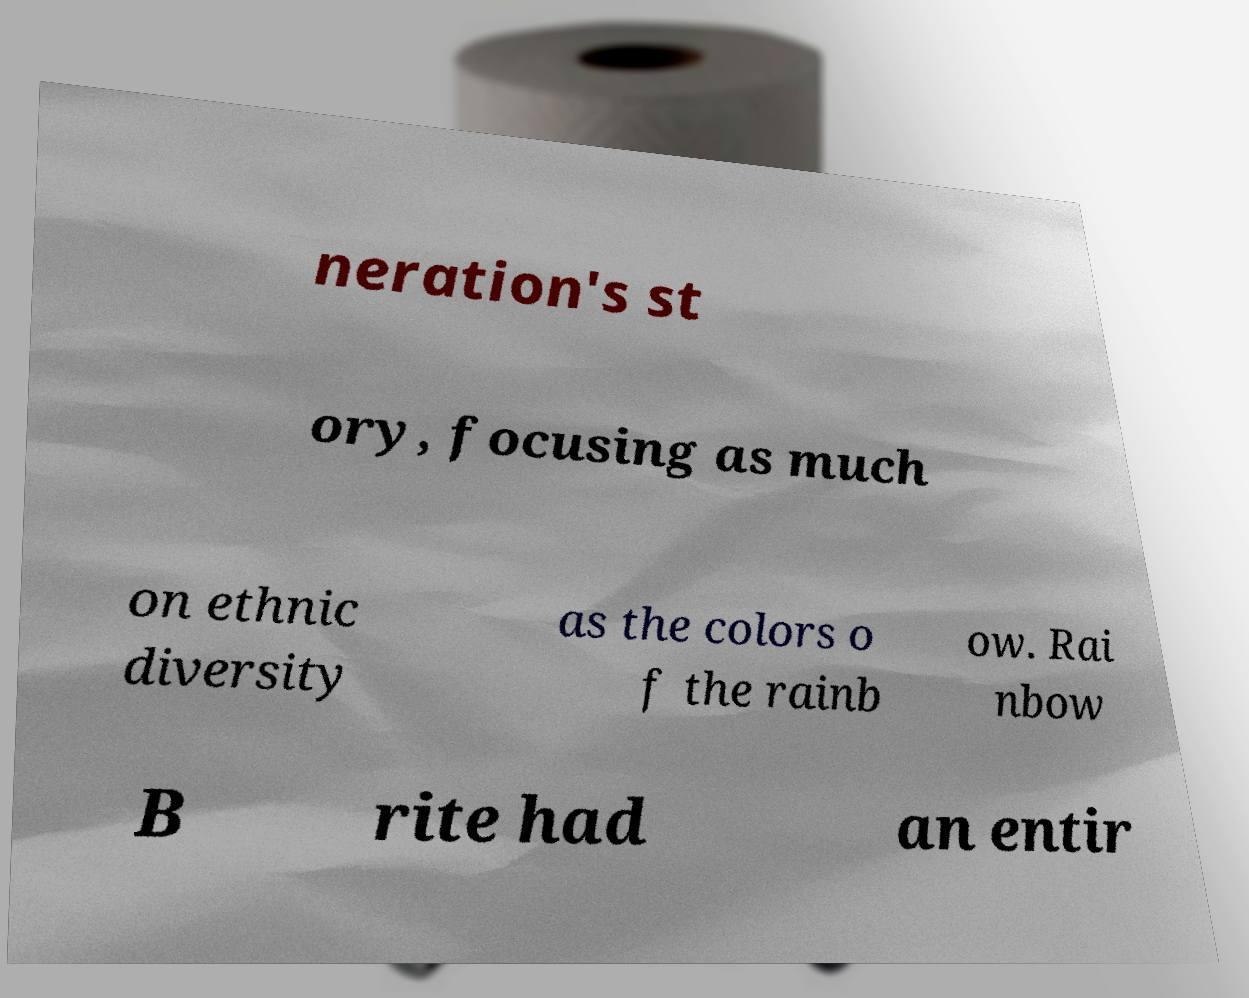What messages or text are displayed in this image? I need them in a readable, typed format. neration's st ory, focusing as much on ethnic diversity as the colors o f the rainb ow. Rai nbow B rite had an entir 